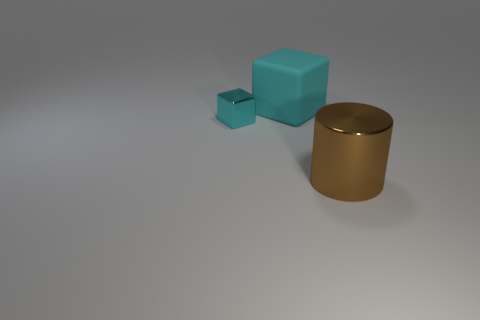Does the matte cube have the same color as the metal object to the left of the large brown object?
Make the answer very short. Yes. What number of cyan matte things are there?
Keep it short and to the point. 1. Is there a tiny thing that has the same color as the large matte block?
Keep it short and to the point. Yes. There is a block that is left of the cyan rubber thing that is behind the metal thing behind the brown metallic object; what color is it?
Your answer should be compact. Cyan. Is the material of the large cyan cube the same as the large object in front of the tiny metal cube?
Provide a succinct answer. No. What material is the small cube?
Your answer should be compact. Metal. There is a tiny cube that is the same color as the big rubber cube; what is its material?
Ensure brevity in your answer.  Metal. What number of other objects are the same material as the brown thing?
Provide a short and direct response. 1. What shape is the object that is in front of the rubber object and right of the tiny cyan shiny thing?
Give a very brief answer. Cylinder. The thing that is the same material as the small cube is what color?
Your answer should be very brief. Brown. 